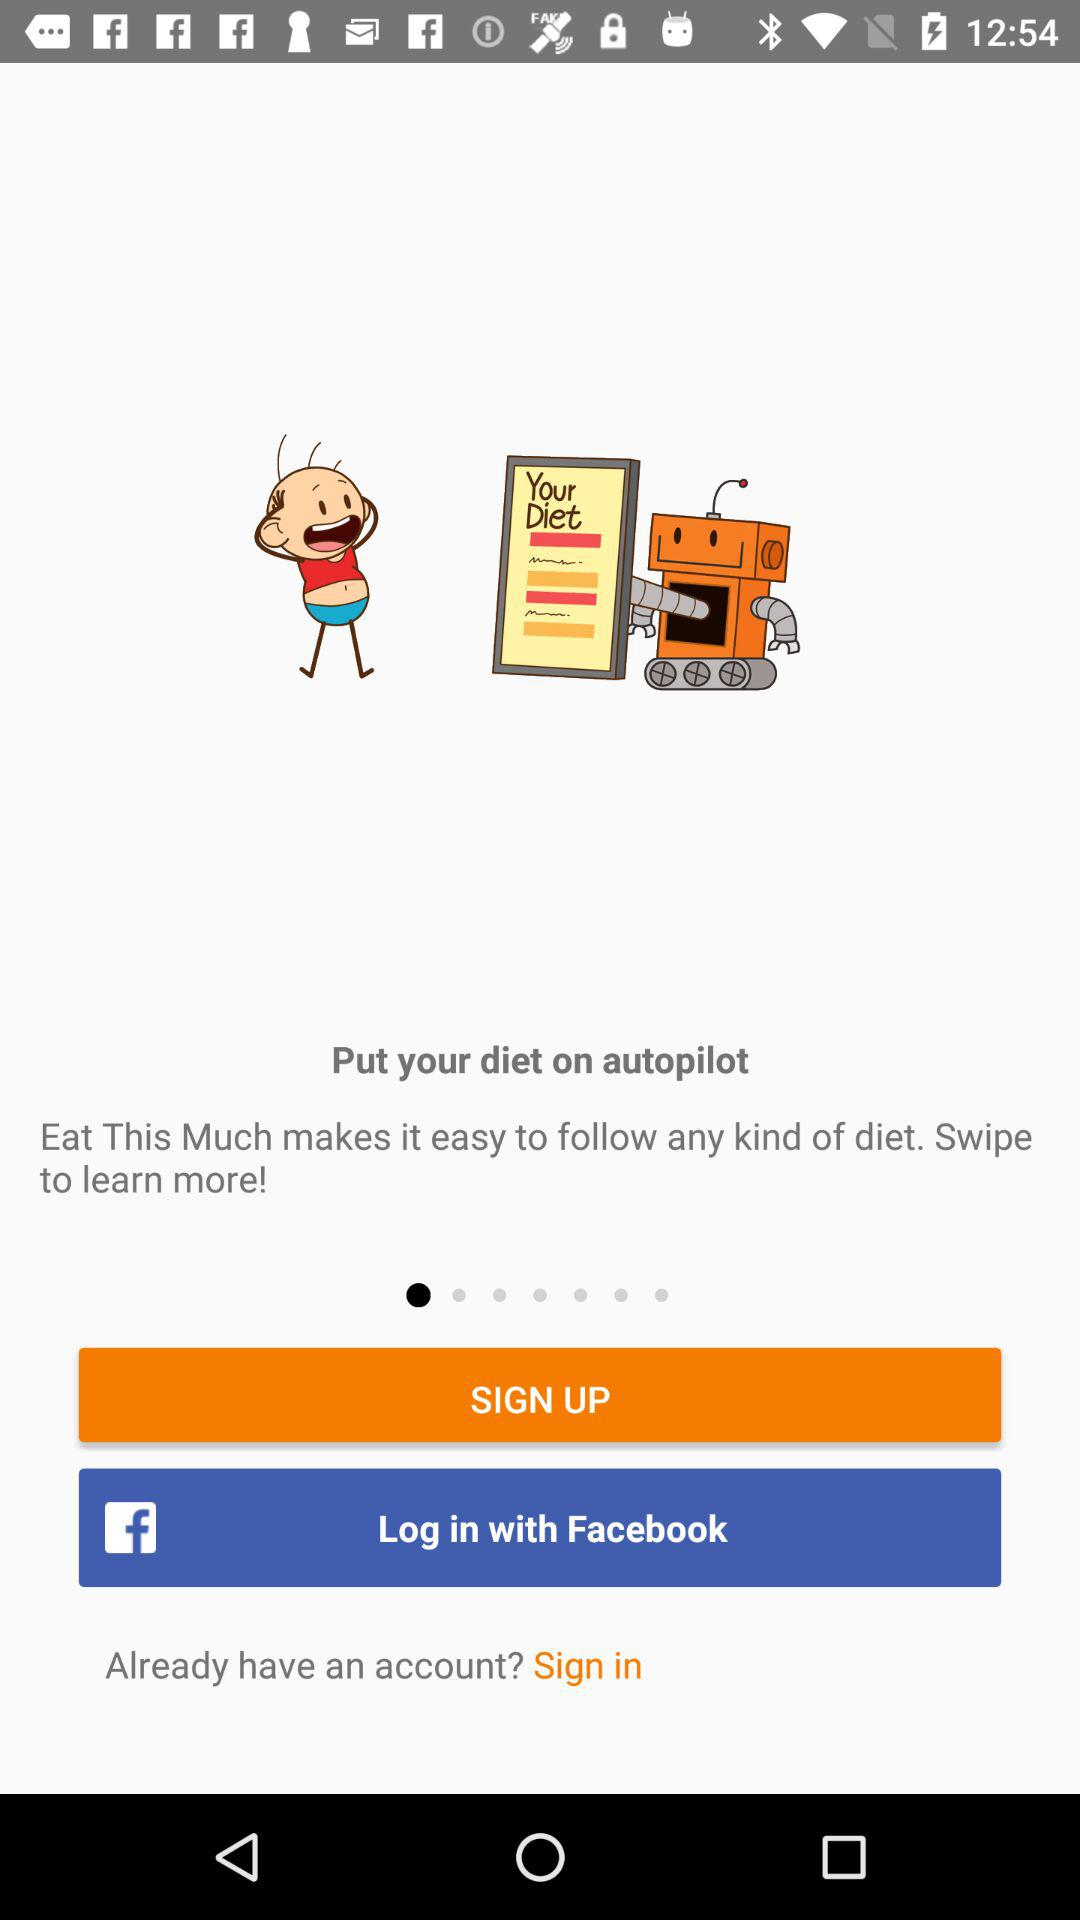What login option is given? The given login option is "Facebook". 